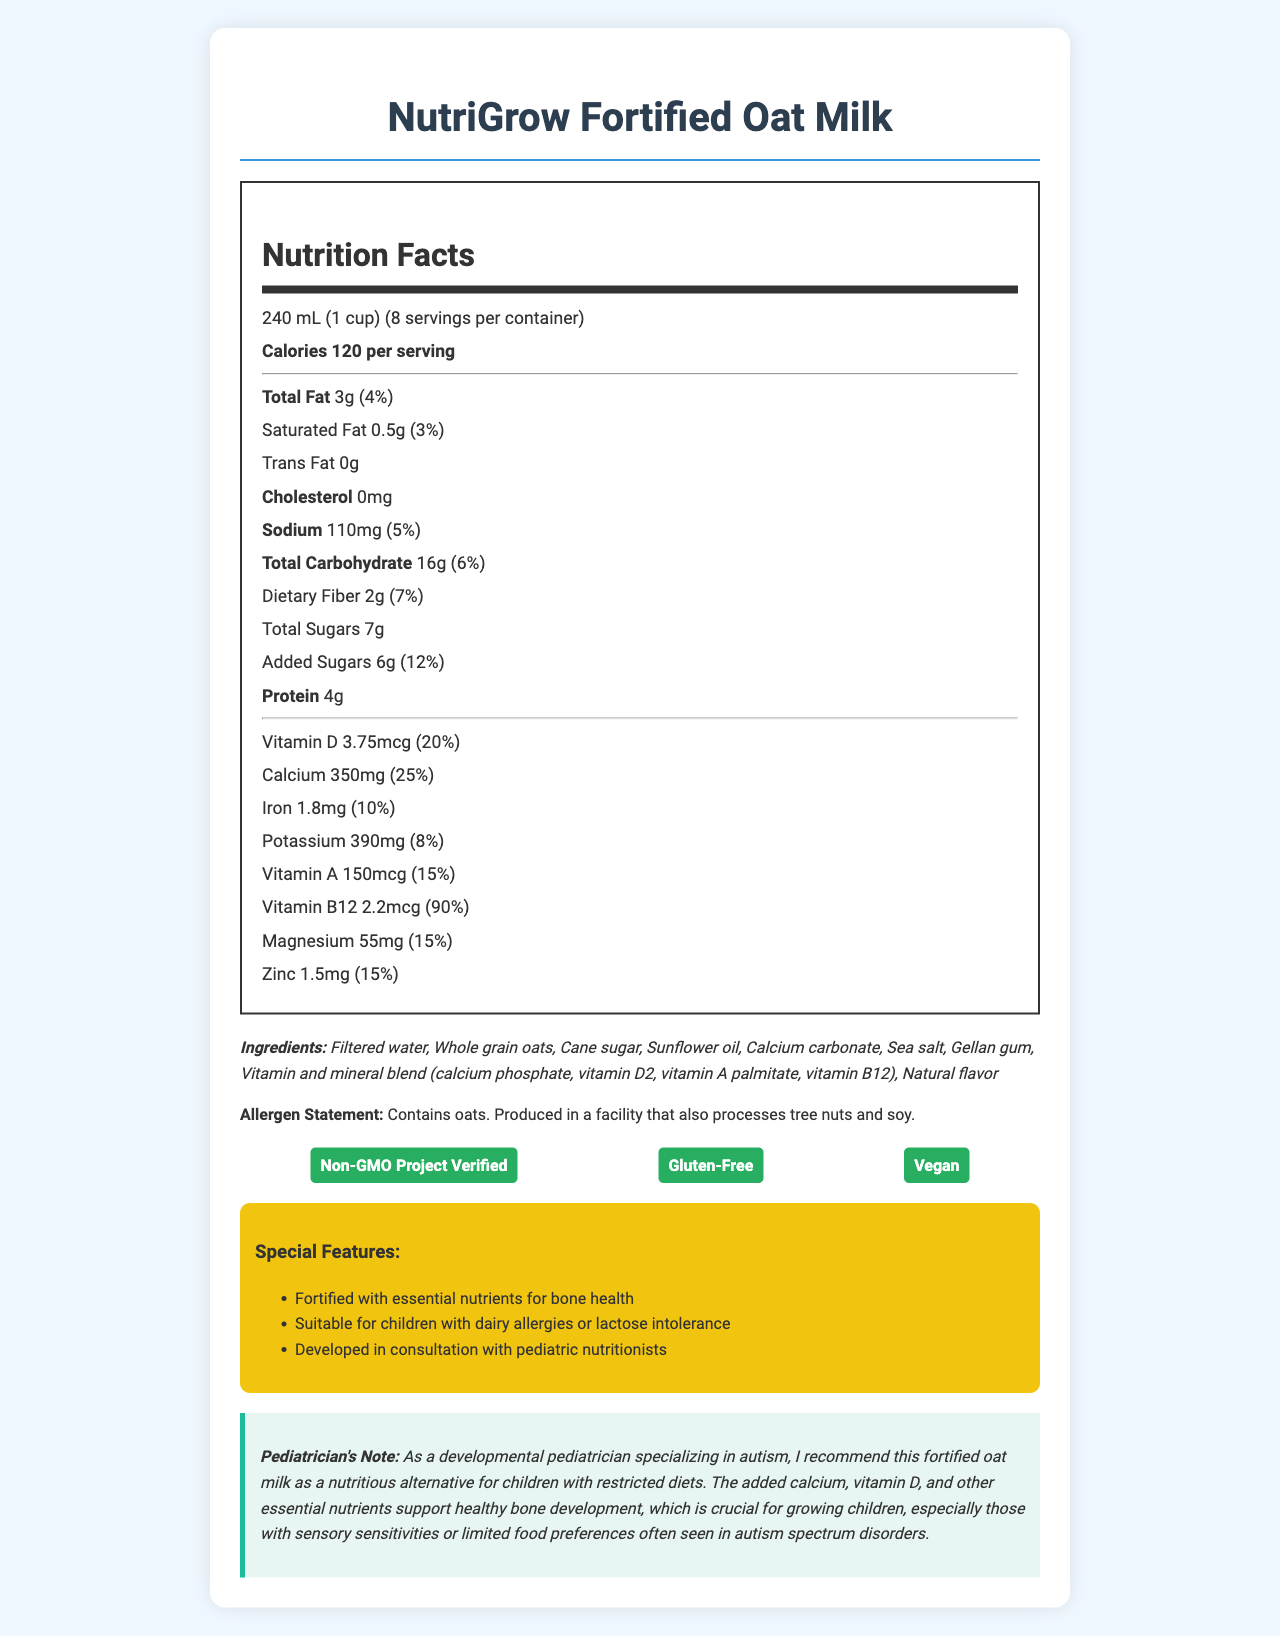what is the serving size? The document lists the serving size as 240 mL (1 cup) under the Nutrition Facts section.
Answer: 240 mL (1 cup) how many calories are there per serving? The calories per serving are prominently displayed in the Nutrition Facts section as 120.
Answer: 120 what is the percentage daily value of calcium per serving? The document states that each serving contains 350mg of calcium, which is 25% of the daily value.
Answer: 25% which vitamin is present at 90% of the daily value? The Nutrition Facts section shows that Vitamin B12 is present at 2.2mcg, which is 90% of the daily value.
Answer: Vitamin B12 does the product contain any trans fat? The document lists 0g of trans fat in the Nutrition Facts section.
Answer: No how much protein is in one serving? According to the Nutrition Facts, one serving includes 4g of protein.
Answer: 4g what are the main ingredients? A. Water, oats, sugar, salt, oil B. Water, soy, wheat, sugar C. Juice, oats, sugar, oil D. Water, cheese, milk, salt The main ingredients are listed as filtered water, whole grain oats, cane sugar, sunflower oil, and sea salt.
Answer: A which of the following might be a concern for children with nut allergies? i. Contains tree nuts ii. Contains soy iii. Contains oats iv. Contains gluten The allergen statement mentions that the product is produced in a facility that also processes tree nuts.
Answer: i is NutriGrow Fortified Oat Milk vegan? The document features a certification badge indicating that the product is vegan.
Answer: Yes summarize the main features of NutriGrow Fortified Oat Milk. The document describes NutriGrow Fortified Oat Milk as a nutritious milk alternative, specifically designed for children with restricted diets. It emphasizes the product's fortification with essential nutrients, allergen information, and special certifications.
Answer: NutriGrow Fortified Oat Milk is a fortified milk alternative designed to support bone health in children with restricted diets such as autism. It contains essential nutrients like calcium, vitamin D, and vitamin B12, is non-GMO, gluten-free, and vegan. This milk alternative is developed in consultation with pediatric nutritionists and contains no cholesterol; it is suitable for children with dairy allergies or lactose intolerance. what is the recommended daily value percentage of Vitamin D per serving? The document specifies that each serving contains 3.75mcg of Vitamin D, equal to 20% of the daily value.
Answer: 20% can this product be purchased online? The document does not provide any details about the availability or purchasing options for this product.
Answer: Not enough information how many servings are there in one container? The document specifies there are 8 servings per container.
Answer: 8 servings 